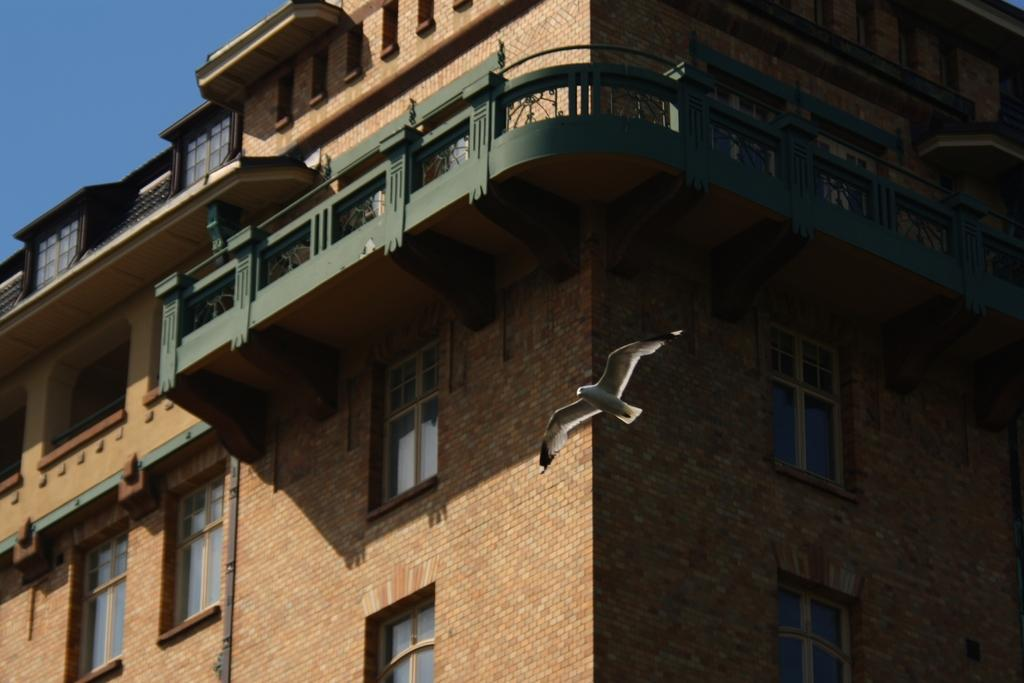What type of structure is present in the image? There is a building in the image. What features can be observed on the building? The building has windows and railing. What can be seen in the background of the image? The blue sky is visible in the background of the image. What type of bait is being used to catch fish in the image? There is no mention of fish or bait in the image; it features a building with windows and railing, and a blue sky in the background. 